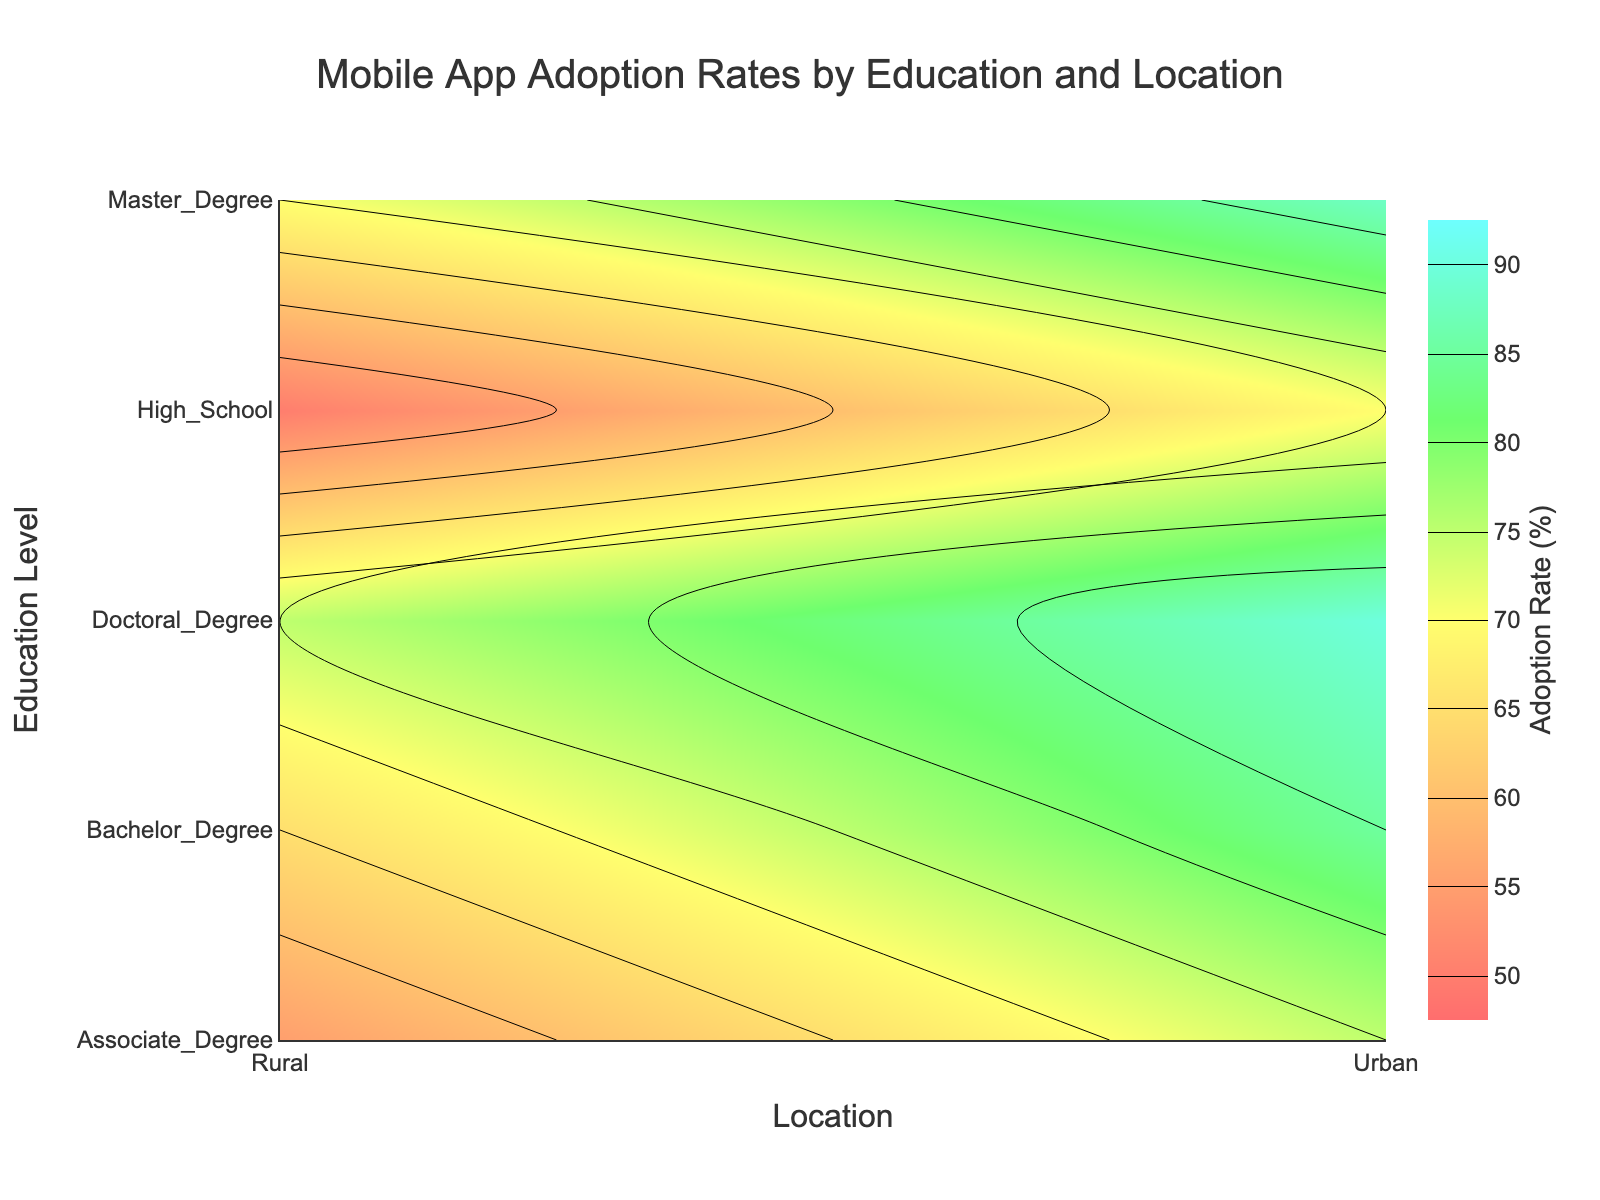What is the title of the plot? The title of the plot can be found at the top center of the figure. It provides a brief summary of what the plot represents.
Answer: Mobile App Adoption Rates by Education and Location What is the mobile app adoption rate for individuals with a Doctoral Degree in rural areas? By looking at the intersection of 'Doctoral Degree' and 'Rural' on the contour plot, you can find the adoption rate.
Answer: 75 Which location has a higher mobile app adoption rate for individuals with a Bachelor's Degree? Compare the adoption rates for 'Bachelor's Degree' on the x-axis for both 'Urban' and 'Rural' on the y-axis.
Answer: Urban What is the range of the contour plot's color scale? The range of the contour plot’s color scale can be identified from the color bar legend's start and end values.
Answer: 50 to 90 What is the difference in mobile app adoption rates between individuals with a Master's Degree in urban and rural areas? Find the adoption rates for 'Master's Degree' in both 'Urban' and 'Rural' locations and calculate the difference. Adoption Rates: Urban = 88, Rural = 70. Difference = 88 - 70.
Answer: 18 How does mobile app adoption rate correlate with education level in rural areas? Look at the trend in adoption rates as you move from 'High School' to 'Doctoral Degree' within the 'Rural' location on the y-axis.
Answer: Adoption rate increases with education level What is the lowest mobile app adoption rate depicted in the plot, and for which group? Identify the smallest value on the contour plot and the corresponding education level and location.
Answer: 50, Rural, High School Does having a higher education level guarantee a higher adoption rate of mobile apps in urban areas? Check if the adoption rate consistently increases with higher education levels in the 'Urban' location.
Answer: Yes Which education level shows the smallest difference in mobile app adoption rates between urban and rural areas? Calculate the differences in adoption rates for each education level and identify the smallest one. Adoption rate differences: High School = 20, Associate Degree = 20, Bachelor's Degree = 20, Master's Degree = 18, Doctoral Degree = 15.
Answer: Doctoral Degree What is the average mobile app adoption rate for all education levels in urban areas? Sum the adoption rates for all education levels in urban areas and divide by the number of education levels. (70 + 75 + 85 + 88 + 90) / 5 = 81.6
Answer: 81.6 